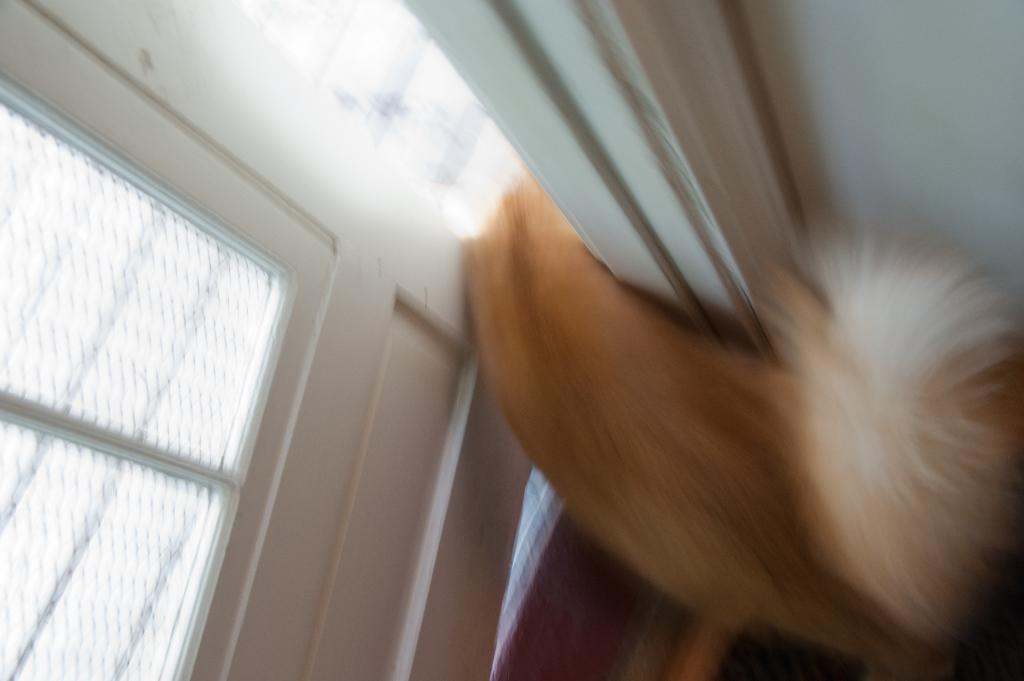Where was the image taken? The image was taken indoors. What can be seen on the left side of the image? There is a door on the left side of the image. What is on the right side of the image? There is a wall on the right side of the image. What type of animal is present in the image? There is a dog on the floor in the image. How does the zephyr affect the dog's behavior in the image? There is no zephyr present in the image, so its effect on the dog's behavior cannot be determined. 